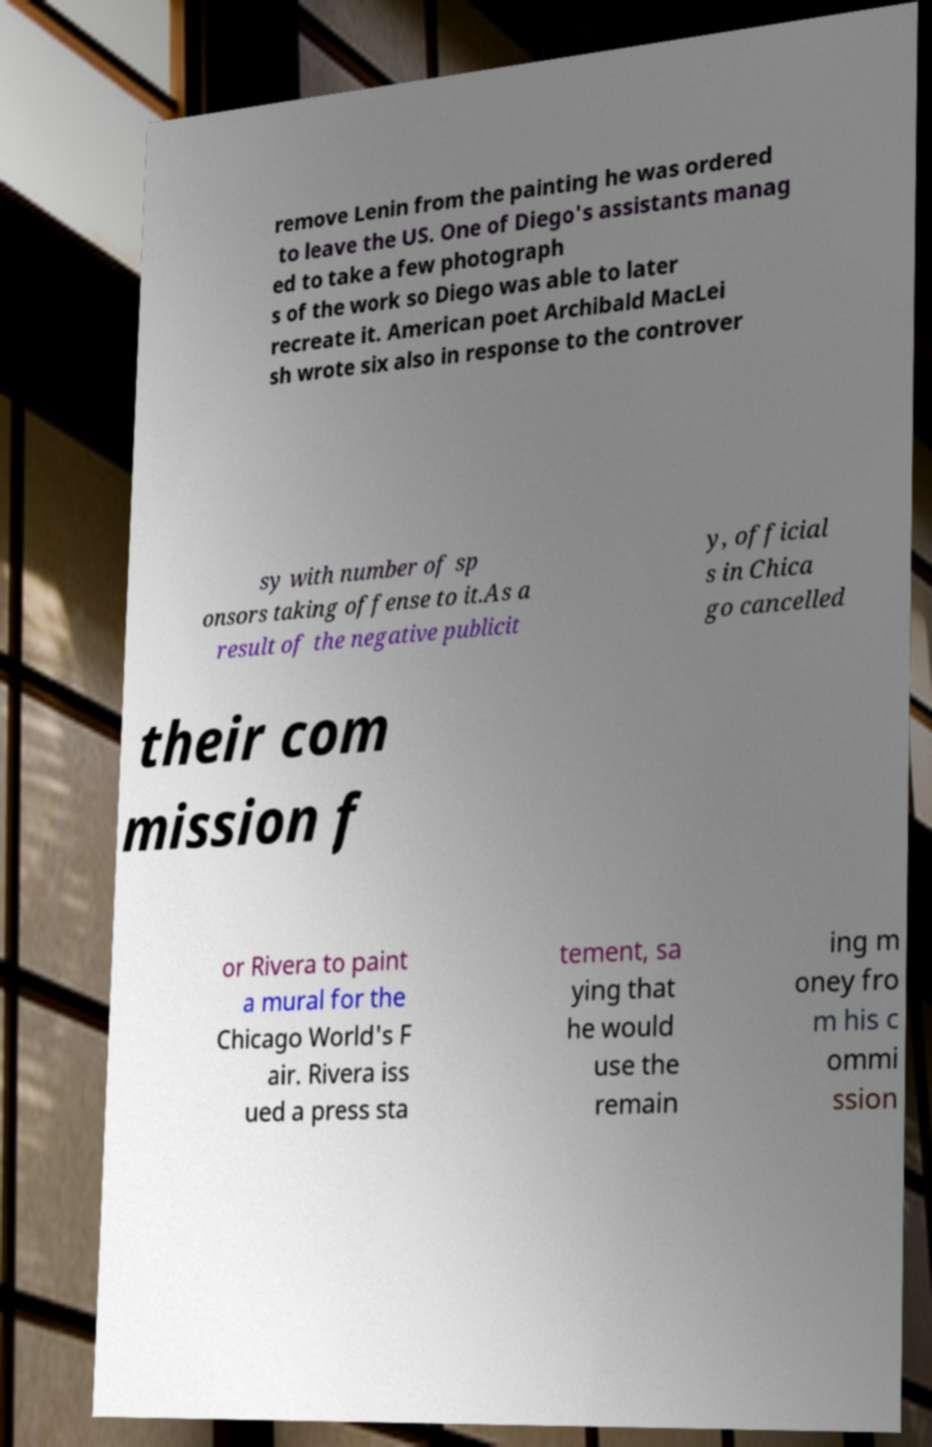For documentation purposes, I need the text within this image transcribed. Could you provide that? remove Lenin from the painting he was ordered to leave the US. One of Diego's assistants manag ed to take a few photograph s of the work so Diego was able to later recreate it. American poet Archibald MacLei sh wrote six also in response to the controver sy with number of sp onsors taking offense to it.As a result of the negative publicit y, official s in Chica go cancelled their com mission f or Rivera to paint a mural for the Chicago World's F air. Rivera iss ued a press sta tement, sa ying that he would use the remain ing m oney fro m his c ommi ssion 